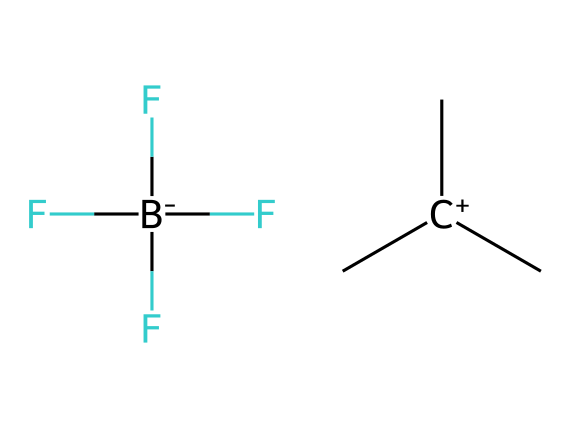What is the total number of atoms in the ionic liquid? The SMILES representation provides a visual structure that can be analyzed. Counting the atoms in the representation, we find three carbon (C) atoms in the cation, one fluorine (F) and one boron (B) atom in the anion, and an additional fluorine from the anion. Thus, there are a total of five atoms.
Answer: five How many distinct elements are present in the ionic liquid? By examining the SMILES structure, we can identify the elements. The cation contains carbon (C) and the anion contains fluorine (F) and boron (B). Thus, the distinct elements are carbon, fluorine, and boron, totaling three.
Answer: three What type of ionic interaction exists in this ionic liquid? The presence of a cation (which is a positively charged species, C+) and an anion (which is a negatively charged species, BF3) indicates that there are ionic interactions. Ionic liquids generally consist of these oppositely charged ions that interact electrostatically.
Answer: ionic What is the charge of the cation in the ionic liquid? The cation is represented as [C+](C)(C). The plus sign indicates that it carries a positive charge. Therefore, the charge of the cation is one positive charge.
Answer: one positive charge Which functional group is present in the anion of the ionic liquid? The anion [B-](F)(F)(F) shows a boron atom bonded to three fluorine atoms. The presence of boron bonded to fluorine suggests it forms a trifluoroborate structure, with the functional group being trifluoroborate.
Answer: trifluoroborate What property of the ionic liquid allows it to be used in flexible, wearable props? Ionic liquids, including this structure, are known for their low volatility and non-flammability, making them suitable for applications where safety and flexibility are required. These properties allow for safe incorporation into flexible, wearable designs in theatre props.
Answer: low volatility 